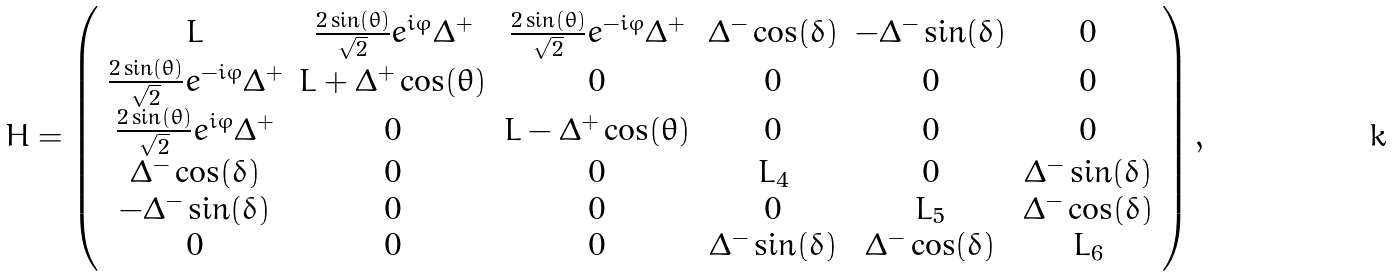Convert formula to latex. <formula><loc_0><loc_0><loc_500><loc_500>H = \left ( \begin{array} { c c c c c c } L & \frac { 2 \sin ( \theta ) } { \sqrt { 2 } } e ^ { i \varphi } \Delta ^ { + } & \frac { 2 \sin ( \theta ) } { \sqrt { 2 } } e ^ { - i \varphi } \Delta ^ { + } & \Delta ^ { - } \cos ( \delta ) & - \Delta ^ { - } \sin ( \delta ) & 0 \\ \frac { 2 \sin ( \theta ) } { \sqrt { 2 } } e ^ { - i \varphi } \Delta ^ { + } & L + \Delta ^ { + } \cos ( \theta ) & 0 & 0 & 0 & 0 \\ \frac { 2 \sin ( \theta ) } { \sqrt { 2 } } e ^ { i \varphi } \Delta ^ { + } & 0 & L - \Delta ^ { + } \cos ( \theta ) & 0 & 0 & 0 \\ \Delta ^ { - } \cos ( \delta ) & 0 & 0 & L _ { 4 } & 0 & \Delta ^ { - } \sin ( \delta ) \\ - \Delta ^ { - } \sin ( \delta ) & 0 & 0 & 0 & L _ { 5 } & \Delta ^ { - } \cos ( \delta ) \\ 0 & 0 & 0 & \Delta ^ { - } \sin ( \delta ) & \Delta ^ { - } \cos ( \delta ) & L _ { 6 } \end{array} \right ) ,</formula> 